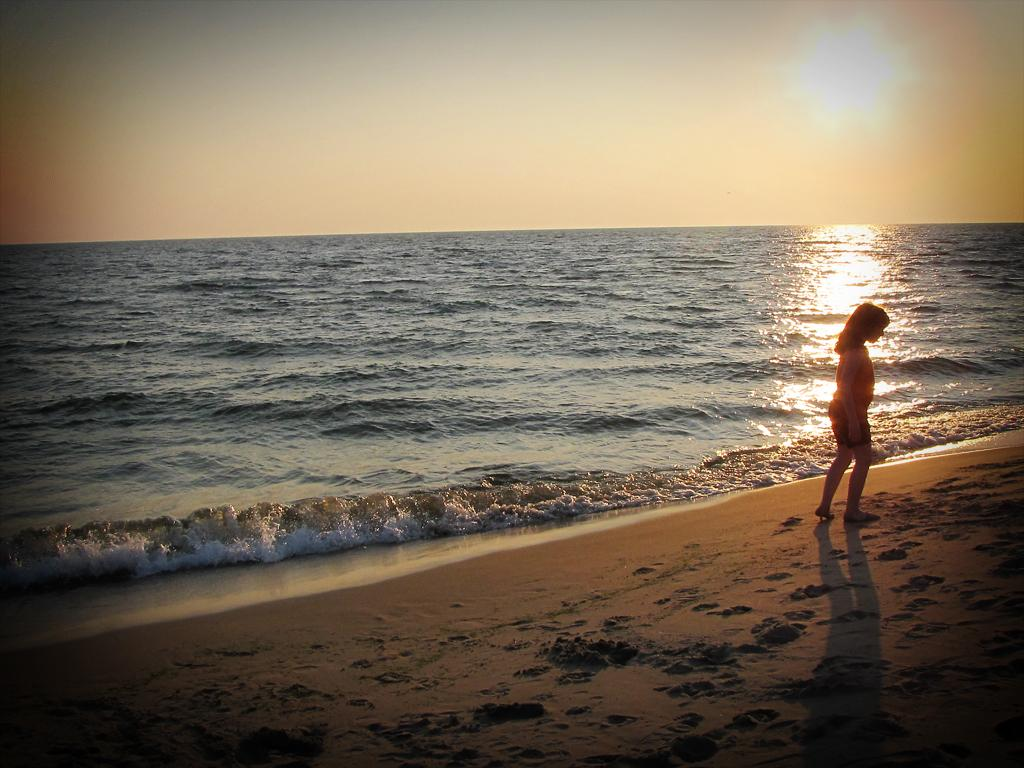What is the woman doing in the image? The woman is walking on the right side of the image. What type of surface is the woman walking on? There is sand at the bottom of the image. What can be seen in the background of the image? There is a beach in the background of the image. What is visible at the top of the image? The sky is visible at the top of the image. Who is the creator of the sand visible in the image? The question of a "creator" for the sand is not applicable, as sand is a naturally occurring substance formed through geological processes. 